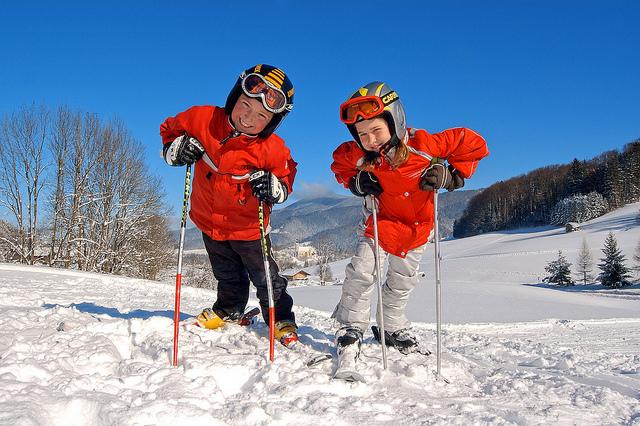Which child looks older?
Keep it brief. Left. How many children is there?
Write a very short answer. 2. Are these children related?
Quick response, please. Yes. 